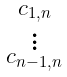<formula> <loc_0><loc_0><loc_500><loc_500>\begin{smallmatrix} c _ { 1 , n } \\ \vdots \\ c _ { n - 1 , n } \end{smallmatrix}</formula> 